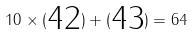Convert formula to latex. <formula><loc_0><loc_0><loc_500><loc_500>1 0 \times ( \begin{matrix} 4 2 \end{matrix} ) + ( \begin{matrix} 4 3 \end{matrix} ) = 6 4</formula> 